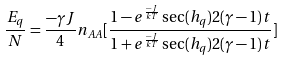Convert formula to latex. <formula><loc_0><loc_0><loc_500><loc_500>\frac { E _ { q } } { N } = \frac { - \gamma J } { 4 } n _ { A A } [ \frac { 1 - e ^ { \frac { - J } { k T } } \sec ( h _ { q } ) 2 ( \gamma - 1 ) t } { 1 + e ^ { \frac { - J } { k T } } \sec ( h _ { q } ) 2 ( \gamma - 1 ) t } ]</formula> 